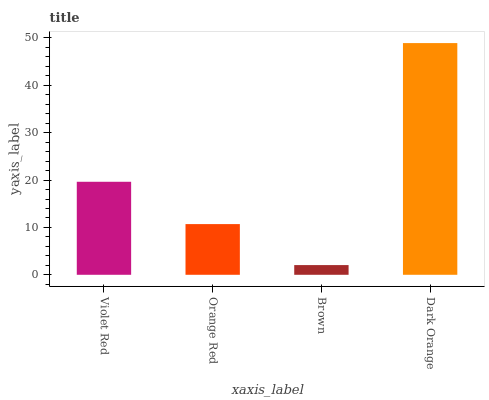Is Brown the minimum?
Answer yes or no. Yes. Is Dark Orange the maximum?
Answer yes or no. Yes. Is Orange Red the minimum?
Answer yes or no. No. Is Orange Red the maximum?
Answer yes or no. No. Is Violet Red greater than Orange Red?
Answer yes or no. Yes. Is Orange Red less than Violet Red?
Answer yes or no. Yes. Is Orange Red greater than Violet Red?
Answer yes or no. No. Is Violet Red less than Orange Red?
Answer yes or no. No. Is Violet Red the high median?
Answer yes or no. Yes. Is Orange Red the low median?
Answer yes or no. Yes. Is Orange Red the high median?
Answer yes or no. No. Is Brown the low median?
Answer yes or no. No. 